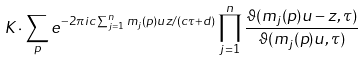Convert formula to latex. <formula><loc_0><loc_0><loc_500><loc_500>K \cdot \sum _ { p } e ^ { - 2 \pi i c \sum _ { j = 1 } ^ { n } m _ { j } ( p ) u z / ( c \tau + d ) } \prod _ { j = 1 } ^ { n } \frac { \vartheta ( m _ { j } ( p ) u - z , \tau ) } { \vartheta ( m _ { j } ( p ) u , \tau ) }</formula> 